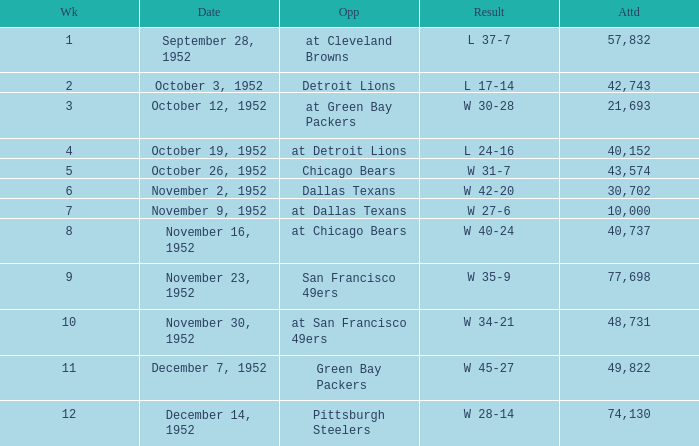When is the last week that has a result of a w 34-21? 10.0. 